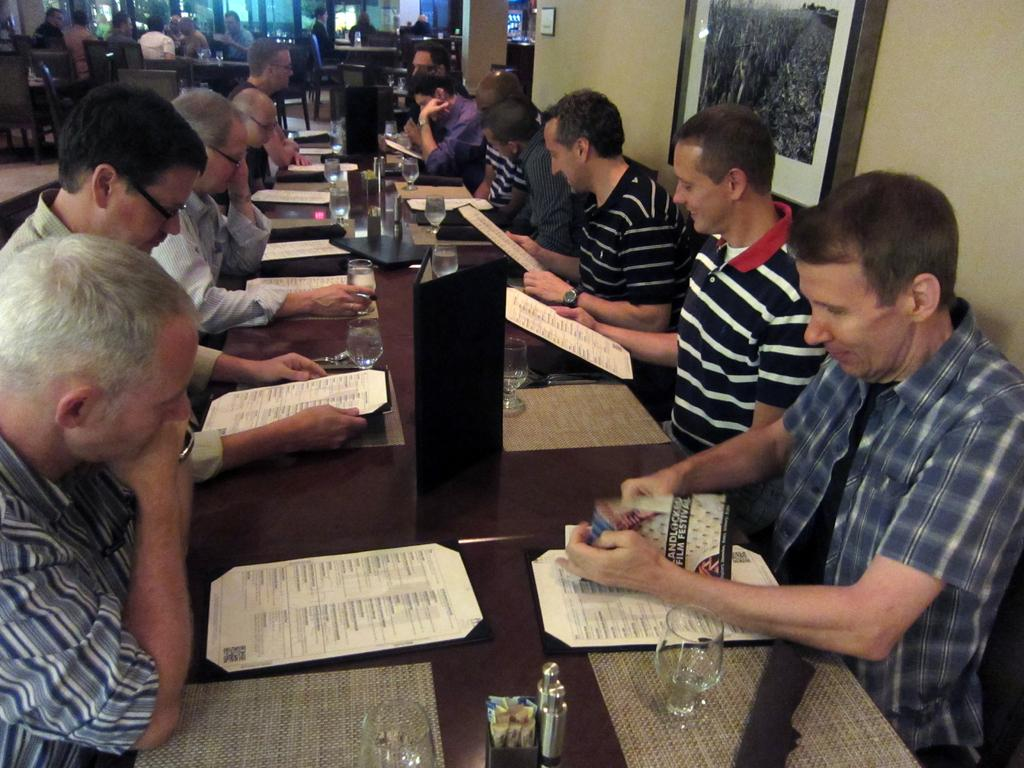How many people are in the image? There is a group of people in the image, but the exact number cannot be determined from the provided facts. What are the people doing in the image? The people are sitting in front of a table. What can be seen on the table? There are objects on the table, but their specific nature cannot be determined from the provided facts. What type of bomb is visible on the ground in the image? There is no bomb or ground present in the image; it features a group of people sitting in front of a table. 